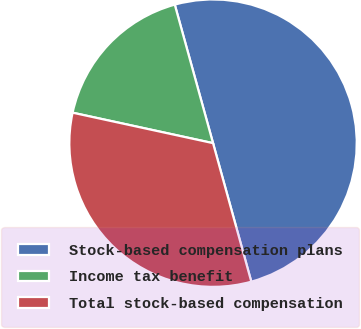Convert chart to OTSL. <chart><loc_0><loc_0><loc_500><loc_500><pie_chart><fcel>Stock-based compensation plans<fcel>Income tax benefit<fcel>Total stock-based compensation<nl><fcel>50.0%<fcel>17.31%<fcel>32.69%<nl></chart> 